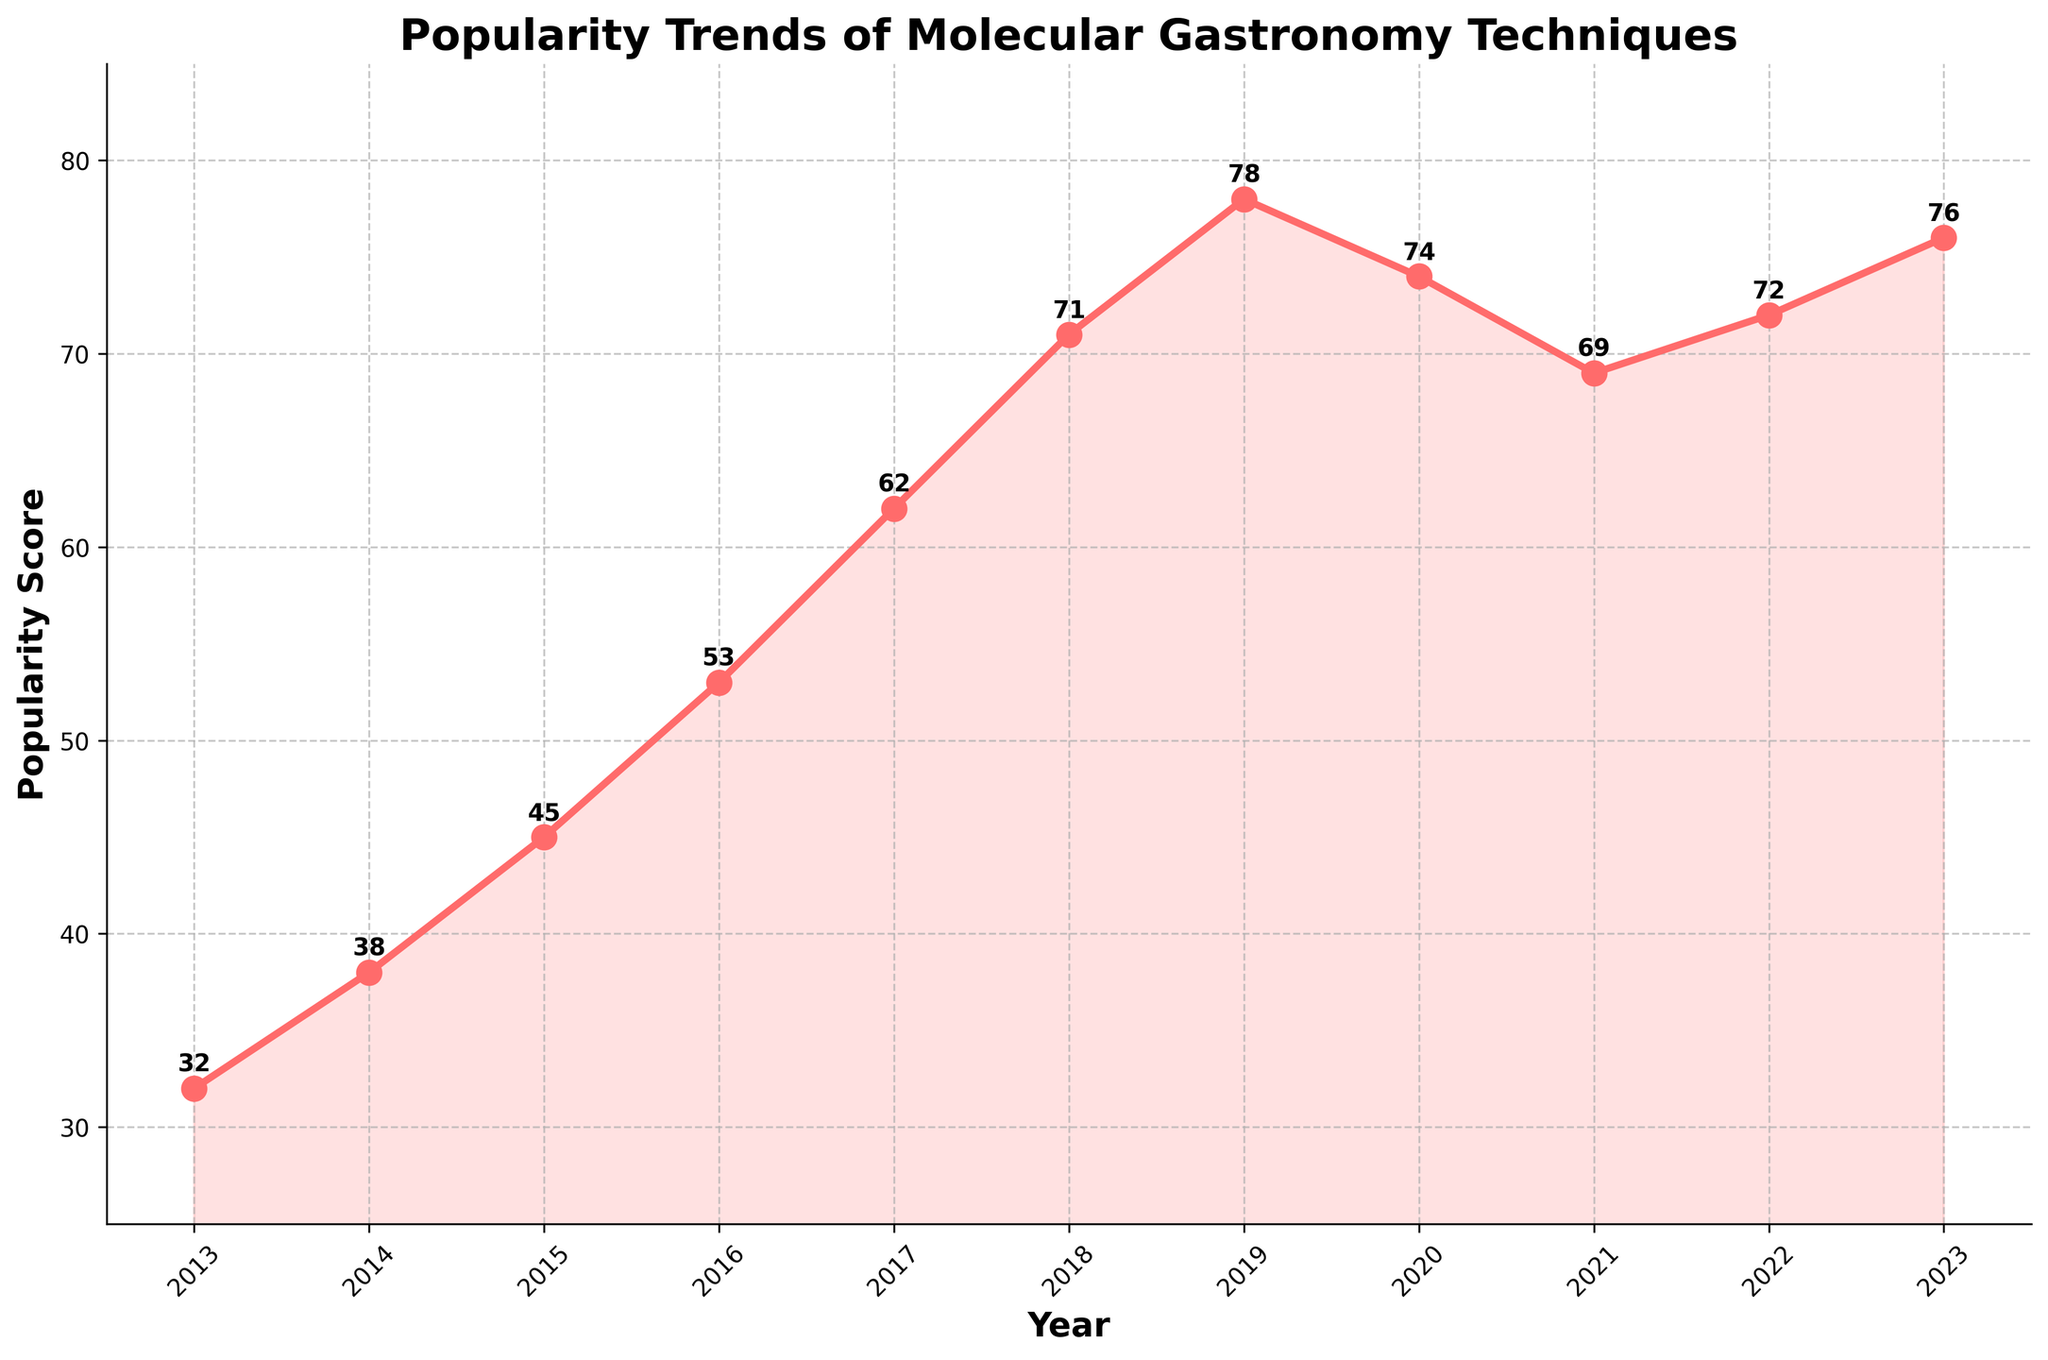What is the highest popularity score and in which year did it occur? By examining the plot, the highest popularity score is 78, which occurs in the year 2019.
Answer: 78, 2019 How does the popularity score in 2020 compare to that in 2019? In 2020, the popularity score is 74, while in 2019 it is 78. 2020's score is 4 points less than 2019's score.
Answer: 2020 is 4 points less than 2019 What is the average popularity score over the past decade? To find the average, sum the popularity scores from 2013 to 2023 and divide by the number of years. (32+38+45+53+62+71+78+74+69+72+76) / 11 = 61.727
Answer: 61.727 Which year had the largest increase in popularity score compared to the previous year? The plot shows that the increase from 2016 to 2017 is the largest (53 to 62, a difference of 9).
Answer: 2017 In which years did the popularity score decrease compared to the previous year? From the plot, the popularity scores decrease in 2020 (74), and 2021 (69).
Answer: 2020, 2021 What is the visual trend of the popularity score from 2013 to 2023? The overall visual trend shows an upward movement from 2013 (32) to 2019 (78), a slight dip in the following two years (2020 - 74 and 2021 - 69), and a recovery in 2022 (72) and 2023 (76).
Answer: Upward, slight dip, recovery Compare the popularity scores of the first and last year in the plot. The popularity score in 2013 is 32 and in 2023 it is 76, showing an increase of 44 points.
Answer: 44 points increase When was the popularity score closest to the median value of the dataset? To find the median value, first sort the scores and find the middle value. Sorted scores: [32, 38, 45, 53, 62, 69, 71, 72, 74, 76, 78]. The median is 69. The score of 69 occurs in the year 2021.
Answer: 2021 